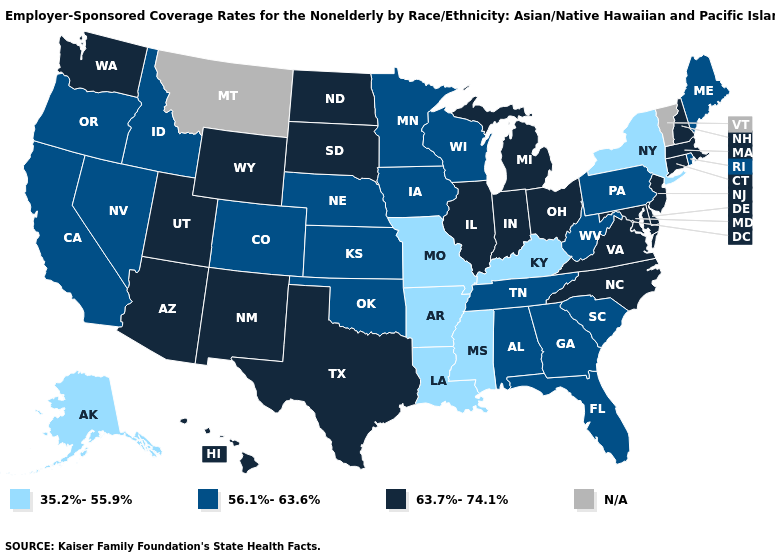Name the states that have a value in the range 35.2%-55.9%?
Keep it brief. Alaska, Arkansas, Kentucky, Louisiana, Mississippi, Missouri, New York. Among the states that border New York , which have the lowest value?
Keep it brief. Pennsylvania. What is the value of Ohio?
Concise answer only. 63.7%-74.1%. What is the lowest value in states that border Missouri?
Quick response, please. 35.2%-55.9%. What is the lowest value in the West?
Be succinct. 35.2%-55.9%. Name the states that have a value in the range 35.2%-55.9%?
Keep it brief. Alaska, Arkansas, Kentucky, Louisiana, Mississippi, Missouri, New York. Name the states that have a value in the range 56.1%-63.6%?
Write a very short answer. Alabama, California, Colorado, Florida, Georgia, Idaho, Iowa, Kansas, Maine, Minnesota, Nebraska, Nevada, Oklahoma, Oregon, Pennsylvania, Rhode Island, South Carolina, Tennessee, West Virginia, Wisconsin. What is the value of Montana?
Concise answer only. N/A. What is the value of Missouri?
Keep it brief. 35.2%-55.9%. What is the highest value in the Northeast ?
Give a very brief answer. 63.7%-74.1%. Does Virginia have the lowest value in the USA?
Quick response, please. No. Among the states that border Idaho , which have the highest value?
Be succinct. Utah, Washington, Wyoming. What is the value of Indiana?
Keep it brief. 63.7%-74.1%. 